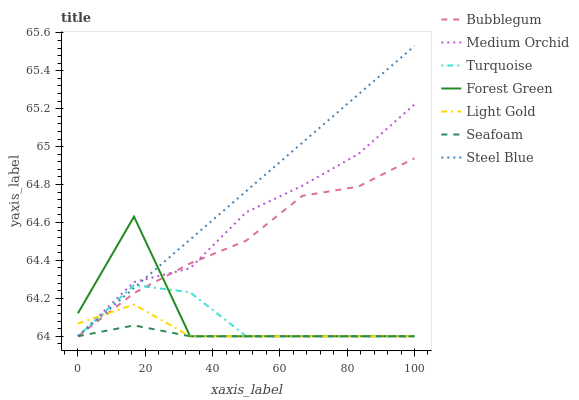Does Seafoam have the minimum area under the curve?
Answer yes or no. Yes. Does Steel Blue have the maximum area under the curve?
Answer yes or no. Yes. Does Medium Orchid have the minimum area under the curve?
Answer yes or no. No. Does Medium Orchid have the maximum area under the curve?
Answer yes or no. No. Is Steel Blue the smoothest?
Answer yes or no. Yes. Is Forest Green the roughest?
Answer yes or no. Yes. Is Medium Orchid the smoothest?
Answer yes or no. No. Is Medium Orchid the roughest?
Answer yes or no. No. Does Turquoise have the lowest value?
Answer yes or no. Yes. Does Steel Blue have the highest value?
Answer yes or no. Yes. Does Medium Orchid have the highest value?
Answer yes or no. No. Does Turquoise intersect Forest Green?
Answer yes or no. Yes. Is Turquoise less than Forest Green?
Answer yes or no. No. Is Turquoise greater than Forest Green?
Answer yes or no. No. 